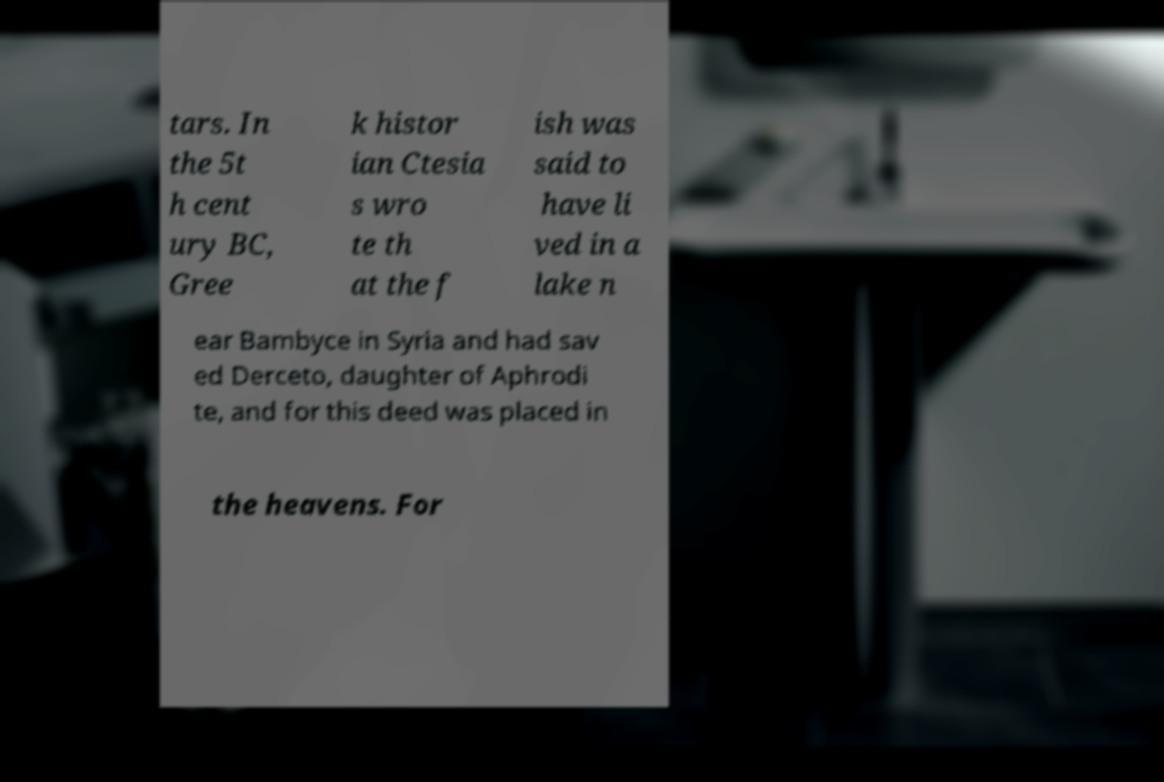What messages or text are displayed in this image? I need them in a readable, typed format. tars. In the 5t h cent ury BC, Gree k histor ian Ctesia s wro te th at the f ish was said to have li ved in a lake n ear Bambyce in Syria and had sav ed Derceto, daughter of Aphrodi te, and for this deed was placed in the heavens. For 